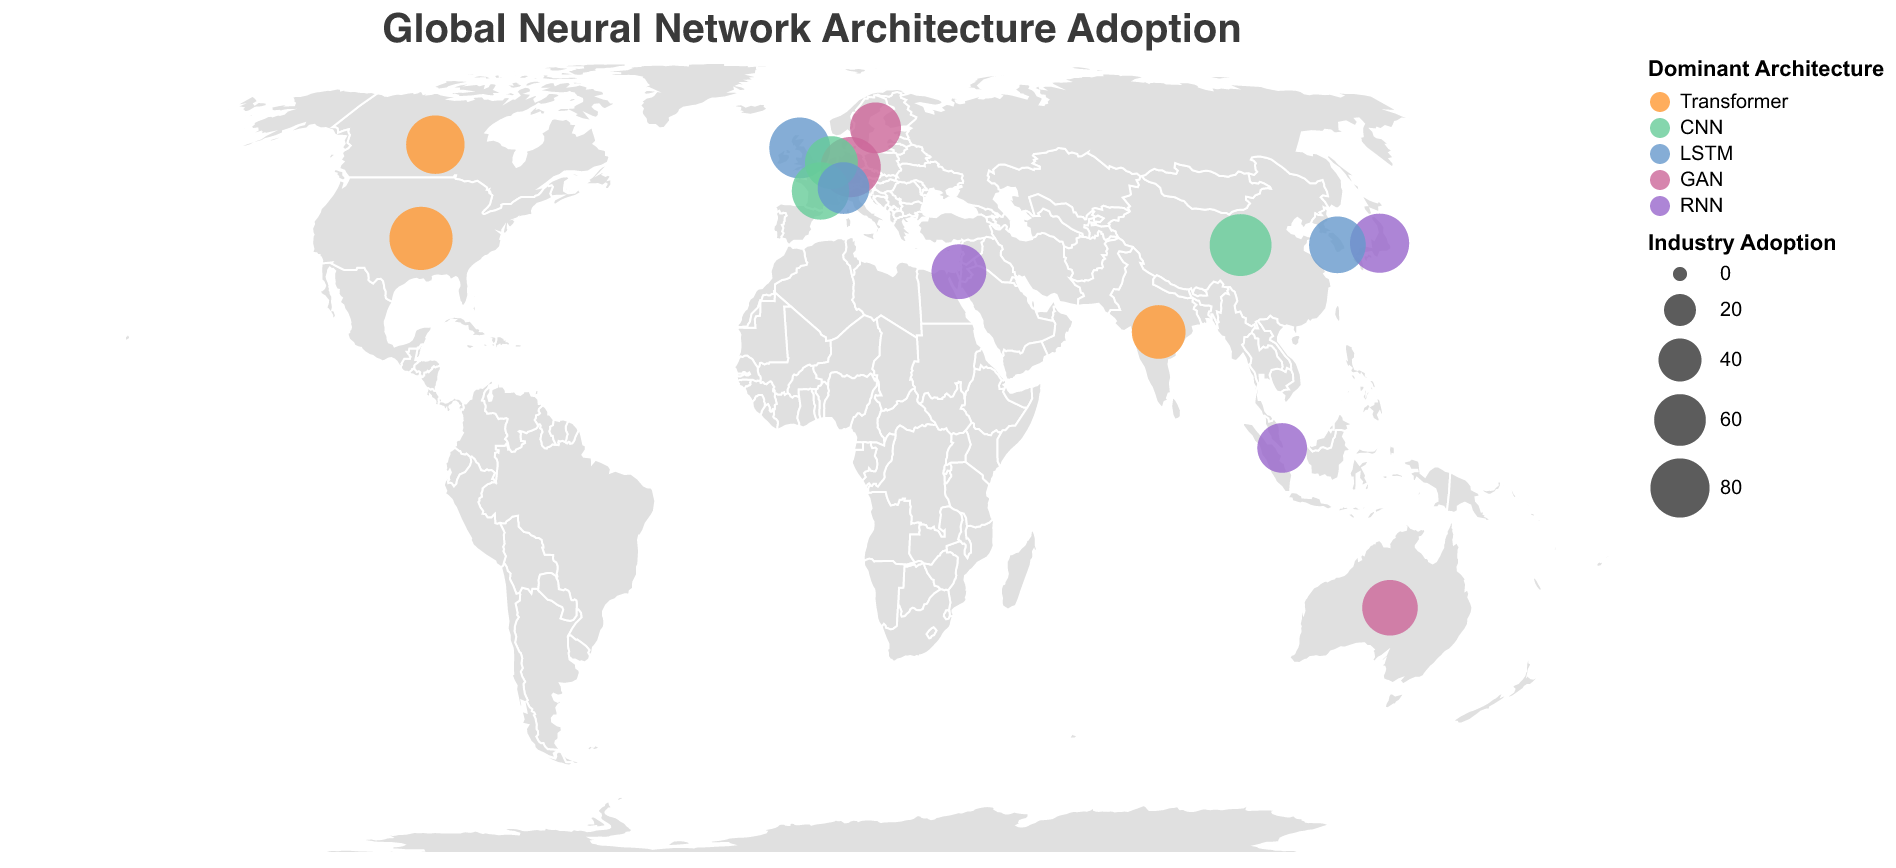What is the title of the figure? The title is usually displayed at the top of the figure. In this case, the provided code specifies the title as "Global Neural Network Architecture Adoption".
Answer: Global Neural Network Architecture Adoption Which country has the highest industry adoption rate? By examining the size of the circles, we can identify the largest one corresponding to the highest industry adoption rate. The data indicates that the United States has the highest industry adoption rate of 92.
Answer: United States What color represents the dominant architecture "RNN"? The legend in the figure specifies colors for different architectures. According to the code, "RNN" is represented by the color "#9966CC", which is a shade of purple or violet.
Answer: Purple/Violet Which countries have high levels of neuroscience collaboration? The tooltip shows the level of neuroscience collaboration for each country. According to the data, the countries with high neuroscience collaboration are the United States, the United Kingdom, Canada, Israel, and Switzerland.
Answer: United States, United Kingdom, Canada, Israel, Switzerland What dominant architecture is most frequently used in the dataset? By examining the number of countries using each dominant architecture based on the color-coded legend and the data, we see that "CNN" is used by China, France, and the Netherlands, making it the most frequent.
Answer: CNN Which country has the lowest academic adoption rate? We need to look for the smallest or one with the least filled data point concerning academic adoption. According to the data, Singapore has the lowest academic adoption rate of 48.
Answer: Singapore What is the average industry adoption rate across all listed countries? To find this, sum all the industry adoption rates and divide by the number of countries: (92+88+85+83+80+78+75+73+70+68+65+63+60+58+55) / 15 = 75.93.
Answer: 75.93 Which two countries use "Transformer" as their dominant architecture and have the highest academic adoption rates within that group? From the data, "Transformer" is used by the United States, Canada, and India. The United States (85) and Canada (70) have the highest academic adoption rates in this group.
Answer: United States, Canada How does the industry adoption rate in Japan compare to that in Germany? According to the figure, Japan has an industry adoption rate of 80, while Germany has a rate of 83. Therefore, Germany has a higher adoption rate than Japan.
Answer: Germany What is the geographical distribution of countries with "Low" neuroscience collaboration? From the data, Japan, South Korea, India, and Singapore have low neuroscience collaborations. These countries are located in East Asia and South Asia.
Answer: East Asia and South Asia 